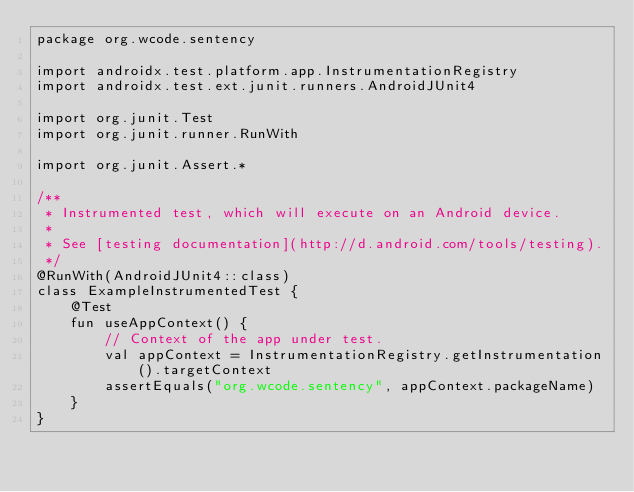Convert code to text. <code><loc_0><loc_0><loc_500><loc_500><_Kotlin_>package org.wcode.sentency

import androidx.test.platform.app.InstrumentationRegistry
import androidx.test.ext.junit.runners.AndroidJUnit4

import org.junit.Test
import org.junit.runner.RunWith

import org.junit.Assert.*

/**
 * Instrumented test, which will execute on an Android device.
 *
 * See [testing documentation](http://d.android.com/tools/testing).
 */
@RunWith(AndroidJUnit4::class)
class ExampleInstrumentedTest {
    @Test
    fun useAppContext() {
        // Context of the app under test.
        val appContext = InstrumentationRegistry.getInstrumentation().targetContext
        assertEquals("org.wcode.sentency", appContext.packageName)
    }
}</code> 